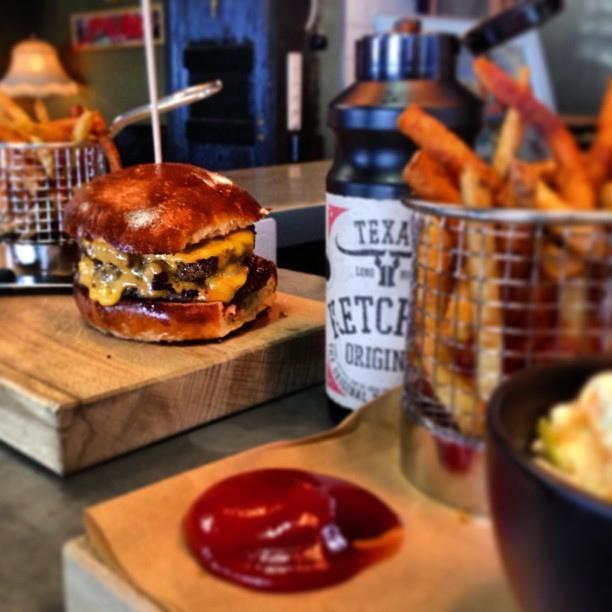Why is there a stick stuck in the cheeseburger? hold together 